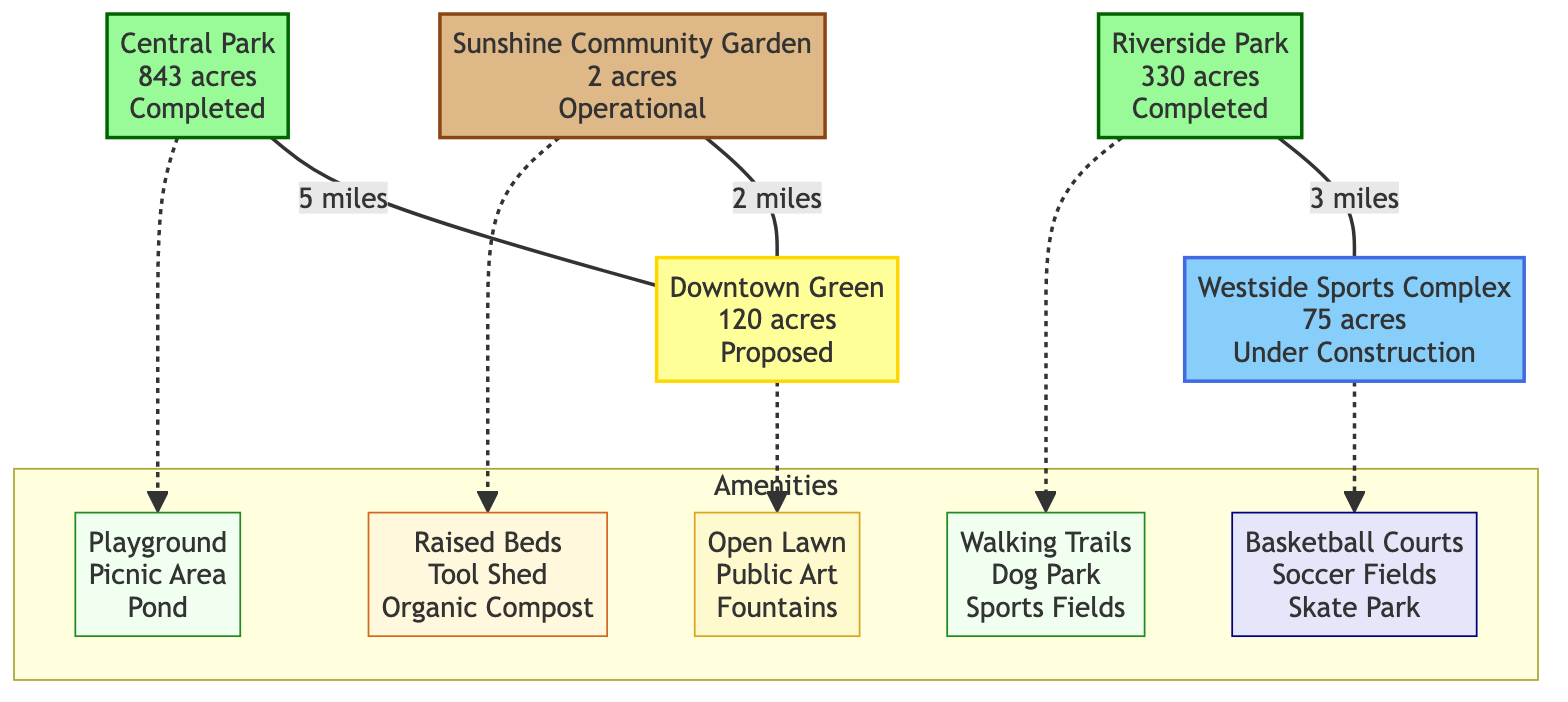What is the size of Central Park? Central Park is labeled with "843 acres" in the diagram.
Answer: 843 acres What type of area is the Sunshine Community Garden? The Sunshine Community Garden is represented by a garden shape and labeled as "Operational," indicating it is a community garden.
Answer: Garden How many proposed green spaces are depicted in the diagram? The diagram shows one proposed green space, which is labeled as "Downtown Green."
Answer: 1 What amenities are planned for Riverside Park? The planned amenities for Riverside Park are listed as "Walking Trails, Dog Park, Sports Fields" in the diagram.
Answer: Walking Trails, Dog Park, Sports Fields What is the status of the Westside Sports Complex? The Westside Sports Complex is indicated to be "Under Construction" in the diagram.
Answer: Under Construction Which park is closest to the Downtown Green? The diagram shows that Central Park is 5 miles from the Downtown Green, while Riverside Park is 3 miles from the Westside Sports Complex; thus, Riverside Park is closer.
Answer: Riverside Park Identify an amenity associated with the Downtown Green. The diagram lists the amenities for the Downtown Green as "Open Lawn, Public Art, Fountains."
Answer: Open Lawn What is the distance between Central Park and the Downtown Green? The diagram states that Central Park is 5 miles away from the Downtown Green.
Answer: 5 miles What color represents recreational areas in the diagram? The recreational areas, such as Westside Sports Complex, are shown in blue (specifically #87CEFA).
Answer: Blue 